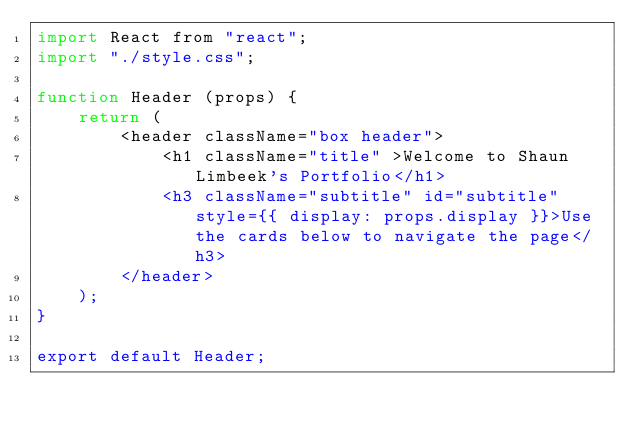Convert code to text. <code><loc_0><loc_0><loc_500><loc_500><_JavaScript_>import React from "react";
import "./style.css";

function Header (props) {
    return (
        <header className="box header">
            <h1 className="title" >Welcome to Shaun Limbeek's Portfolio</h1>
            <h3 className="subtitle" id="subtitle" style={{ display: props.display }}>Use the cards below to navigate the page</h3>
        </header>
    );
}

export default Header;</code> 